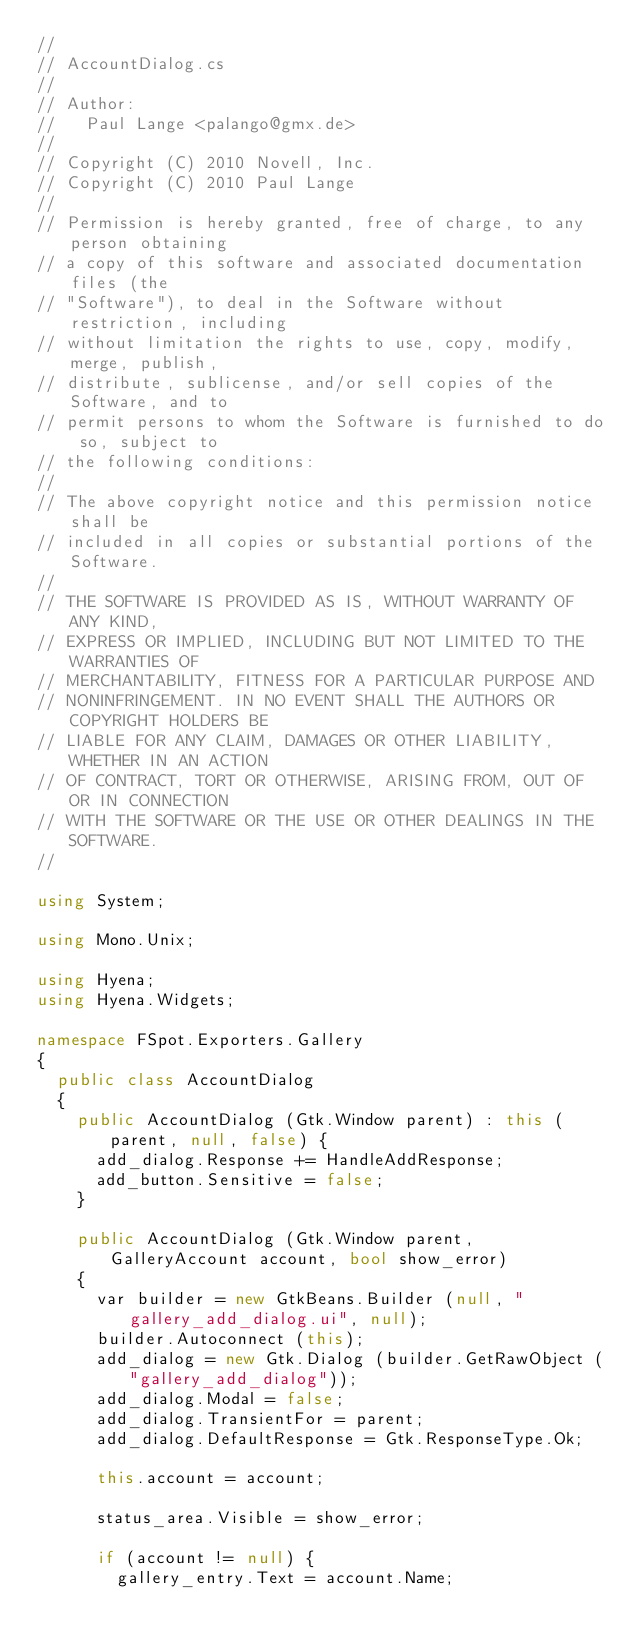<code> <loc_0><loc_0><loc_500><loc_500><_C#_>//
// AccountDialog.cs
//
// Author:
//   Paul Lange <palango@gmx.de>
//
// Copyright (C) 2010 Novell, Inc.
// Copyright (C) 2010 Paul Lange
//
// Permission is hereby granted, free of charge, to any person obtaining
// a copy of this software and associated documentation files (the
// "Software"), to deal in the Software without restriction, including
// without limitation the rights to use, copy, modify, merge, publish,
// distribute, sublicense, and/or sell copies of the Software, and to
// permit persons to whom the Software is furnished to do so, subject to
// the following conditions:
//
// The above copyright notice and this permission notice shall be
// included in all copies or substantial portions of the Software.
//
// THE SOFTWARE IS PROVIDED AS IS, WITHOUT WARRANTY OF ANY KIND,
// EXPRESS OR IMPLIED, INCLUDING BUT NOT LIMITED TO THE WARRANTIES OF
// MERCHANTABILITY, FITNESS FOR A PARTICULAR PURPOSE AND
// NONINFRINGEMENT. IN NO EVENT SHALL THE AUTHORS OR COPYRIGHT HOLDERS BE
// LIABLE FOR ANY CLAIM, DAMAGES OR OTHER LIABILITY, WHETHER IN AN ACTION
// OF CONTRACT, TORT OR OTHERWISE, ARISING FROM, OUT OF OR IN CONNECTION
// WITH THE SOFTWARE OR THE USE OR OTHER DEALINGS IN THE SOFTWARE.
//

using System;

using Mono.Unix;

using Hyena;
using Hyena.Widgets;

namespace FSpot.Exporters.Gallery
{
	public class AccountDialog
	{
		public AccountDialog (Gtk.Window parent) : this (parent, null, false) {
			add_dialog.Response += HandleAddResponse;
			add_button.Sensitive = false;
		}

		public AccountDialog (Gtk.Window parent, GalleryAccount account, bool show_error)
		{
			var builder = new GtkBeans.Builder (null, "gallery_add_dialog.ui", null);
			builder.Autoconnect (this);
			add_dialog = new Gtk.Dialog (builder.GetRawObject ("gallery_add_dialog"));
			add_dialog.Modal = false;
			add_dialog.TransientFor = parent;
			add_dialog.DefaultResponse = Gtk.ResponseType.Ok;

			this.account = account;

			status_area.Visible = show_error;

			if (account != null) {
				gallery_entry.Text = account.Name;</code> 